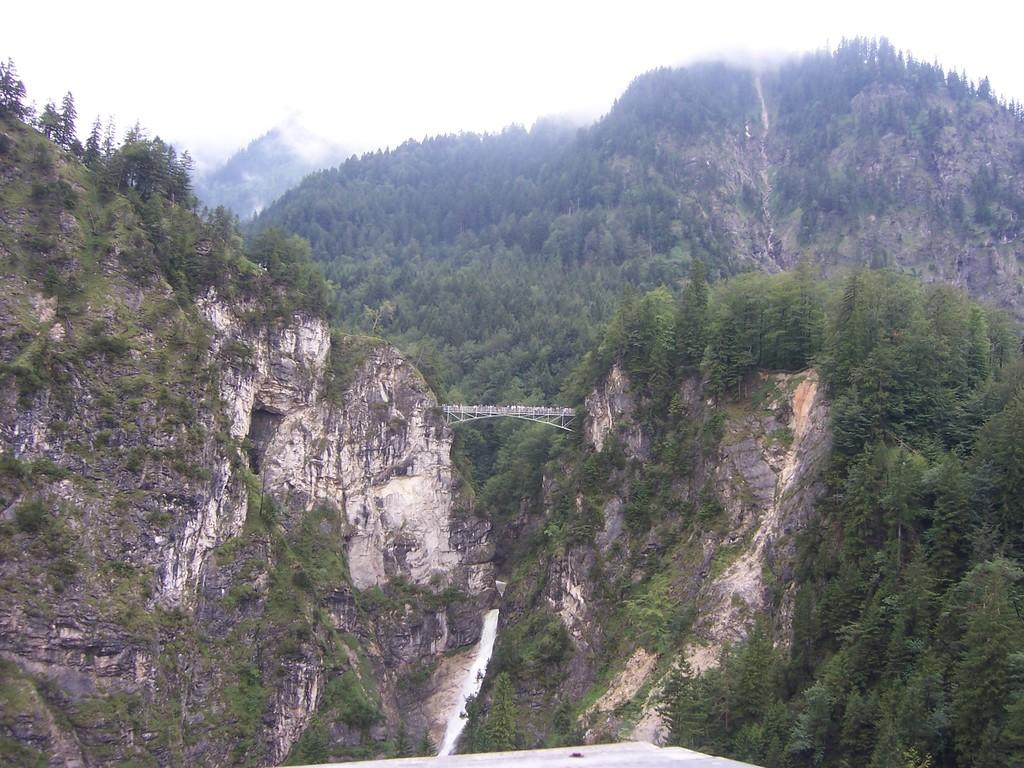What type of bridge is featured in the image? There is a cantilever bridge in the image. How would you describe the appearance of the bridge? The bridge is beautiful. What can be seen on both sides of the bridge? There are huge mountains on both sides of the bridge. What type of vegetation is visible on the mountain in the background? There is a mountain full of trees visible in the background. How many toes does the bridge have in the image? Bridges do not have toes, as they are inanimate objects. The question is not applicable to the image. 